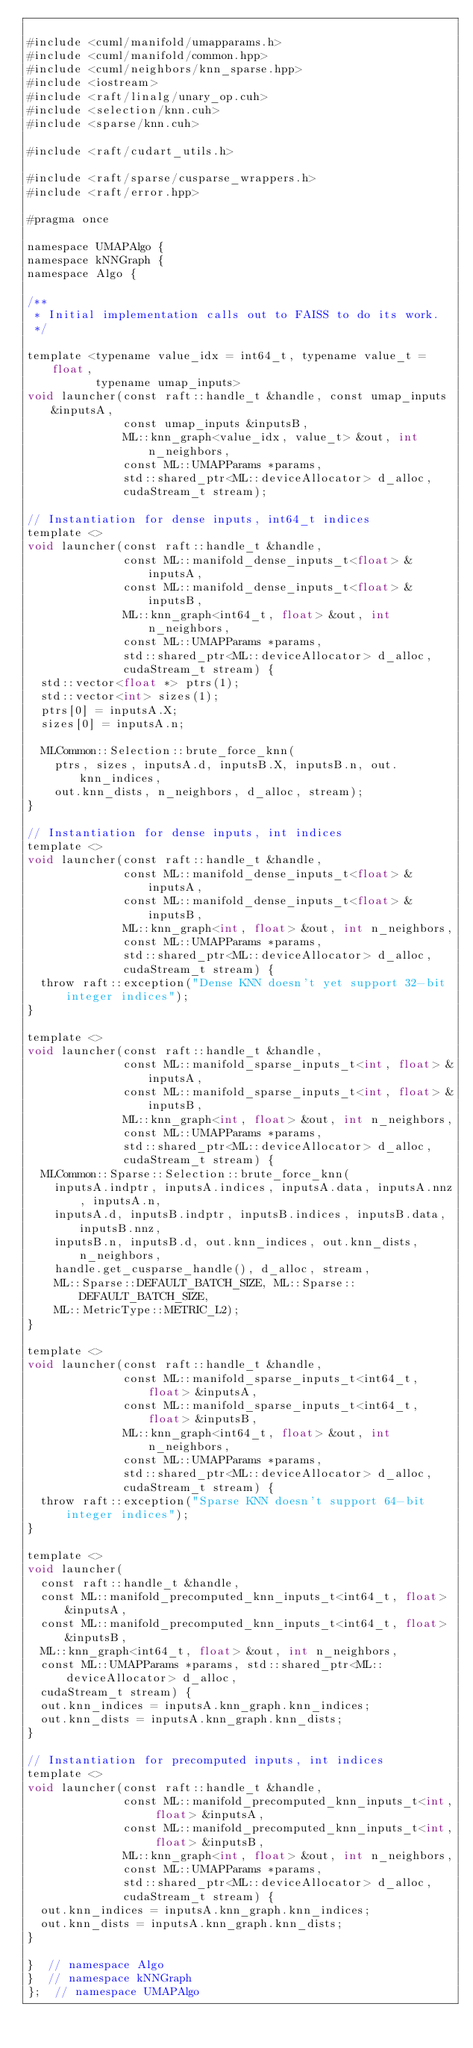Convert code to text. <code><loc_0><loc_0><loc_500><loc_500><_Cuda_>
#include <cuml/manifold/umapparams.h>
#include <cuml/manifold/common.hpp>
#include <cuml/neighbors/knn_sparse.hpp>
#include <iostream>
#include <raft/linalg/unary_op.cuh>
#include <selection/knn.cuh>
#include <sparse/knn.cuh>

#include <raft/cudart_utils.h>

#include <raft/sparse/cusparse_wrappers.h>
#include <raft/error.hpp>

#pragma once

namespace UMAPAlgo {
namespace kNNGraph {
namespace Algo {

/**
 * Initial implementation calls out to FAISS to do its work.
 */

template <typename value_idx = int64_t, typename value_t = float,
          typename umap_inputs>
void launcher(const raft::handle_t &handle, const umap_inputs &inputsA,
              const umap_inputs &inputsB,
              ML::knn_graph<value_idx, value_t> &out, int n_neighbors,
              const ML::UMAPParams *params,
              std::shared_ptr<ML::deviceAllocator> d_alloc,
              cudaStream_t stream);

// Instantiation for dense inputs, int64_t indices
template <>
void launcher(const raft::handle_t &handle,
              const ML::manifold_dense_inputs_t<float> &inputsA,
              const ML::manifold_dense_inputs_t<float> &inputsB,
              ML::knn_graph<int64_t, float> &out, int n_neighbors,
              const ML::UMAPParams *params,
              std::shared_ptr<ML::deviceAllocator> d_alloc,
              cudaStream_t stream) {
  std::vector<float *> ptrs(1);
  std::vector<int> sizes(1);
  ptrs[0] = inputsA.X;
  sizes[0] = inputsA.n;

  MLCommon::Selection::brute_force_knn(
    ptrs, sizes, inputsA.d, inputsB.X, inputsB.n, out.knn_indices,
    out.knn_dists, n_neighbors, d_alloc, stream);
}

// Instantiation for dense inputs, int indices
template <>
void launcher(const raft::handle_t &handle,
              const ML::manifold_dense_inputs_t<float> &inputsA,
              const ML::manifold_dense_inputs_t<float> &inputsB,
              ML::knn_graph<int, float> &out, int n_neighbors,
              const ML::UMAPParams *params,
              std::shared_ptr<ML::deviceAllocator> d_alloc,
              cudaStream_t stream) {
  throw raft::exception("Dense KNN doesn't yet support 32-bit integer indices");
}

template <>
void launcher(const raft::handle_t &handle,
              const ML::manifold_sparse_inputs_t<int, float> &inputsA,
              const ML::manifold_sparse_inputs_t<int, float> &inputsB,
              ML::knn_graph<int, float> &out, int n_neighbors,
              const ML::UMAPParams *params,
              std::shared_ptr<ML::deviceAllocator> d_alloc,
              cudaStream_t stream) {
  MLCommon::Sparse::Selection::brute_force_knn(
    inputsA.indptr, inputsA.indices, inputsA.data, inputsA.nnz, inputsA.n,
    inputsA.d, inputsB.indptr, inputsB.indices, inputsB.data, inputsB.nnz,
    inputsB.n, inputsB.d, out.knn_indices, out.knn_dists, n_neighbors,
    handle.get_cusparse_handle(), d_alloc, stream,
    ML::Sparse::DEFAULT_BATCH_SIZE, ML::Sparse::DEFAULT_BATCH_SIZE,
    ML::MetricType::METRIC_L2);
}

template <>
void launcher(const raft::handle_t &handle,
              const ML::manifold_sparse_inputs_t<int64_t, float> &inputsA,
              const ML::manifold_sparse_inputs_t<int64_t, float> &inputsB,
              ML::knn_graph<int64_t, float> &out, int n_neighbors,
              const ML::UMAPParams *params,
              std::shared_ptr<ML::deviceAllocator> d_alloc,
              cudaStream_t stream) {
  throw raft::exception("Sparse KNN doesn't support 64-bit integer indices");
}

template <>
void launcher(
  const raft::handle_t &handle,
  const ML::manifold_precomputed_knn_inputs_t<int64_t, float> &inputsA,
  const ML::manifold_precomputed_knn_inputs_t<int64_t, float> &inputsB,
  ML::knn_graph<int64_t, float> &out, int n_neighbors,
  const ML::UMAPParams *params, std::shared_ptr<ML::deviceAllocator> d_alloc,
  cudaStream_t stream) {
  out.knn_indices = inputsA.knn_graph.knn_indices;
  out.knn_dists = inputsA.knn_graph.knn_dists;
}

// Instantiation for precomputed inputs, int indices
template <>
void launcher(const raft::handle_t &handle,
              const ML::manifold_precomputed_knn_inputs_t<int, float> &inputsA,
              const ML::manifold_precomputed_knn_inputs_t<int, float> &inputsB,
              ML::knn_graph<int, float> &out, int n_neighbors,
              const ML::UMAPParams *params,
              std::shared_ptr<ML::deviceAllocator> d_alloc,
              cudaStream_t stream) {
  out.knn_indices = inputsA.knn_graph.knn_indices;
  out.knn_dists = inputsA.knn_graph.knn_dists;
}

}  // namespace Algo
}  // namespace kNNGraph
};  // namespace UMAPAlgo
</code> 